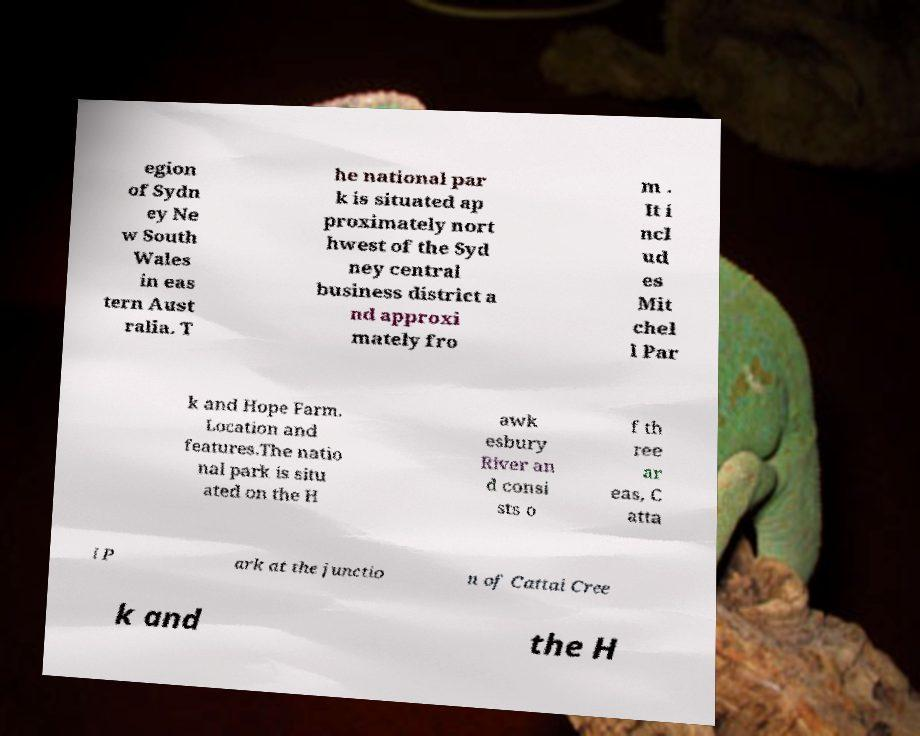Can you read and provide the text displayed in the image?This photo seems to have some interesting text. Can you extract and type it out for me? egion of Sydn ey Ne w South Wales in eas tern Aust ralia. T he national par k is situated ap proximately nort hwest of the Syd ney central business district a nd approxi mately fro m . It i ncl ud es Mit chel l Par k and Hope Farm. Location and features.The natio nal park is situ ated on the H awk esbury River an d consi sts o f th ree ar eas, C atta i P ark at the junctio n of Cattai Cree k and the H 